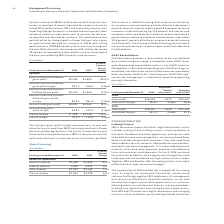According to International Business Machines's financial document, What led to increase in Global Financing total revenue? an increase in internal revenue, partially offset by a decrease in external revenue.. The document states: "se in Global Financing total revenue was driven by an increase in internal revenue, partially offset by a decrease in external revenue. Internal reven..." Also, What led to decline in External revenue  a decrease in external used equipment sales (down 30.8 percent), partially offset by an increase in external financing (up 4.9 percent).. The document states: "ent). External revenue declined 6.3 percent due to a decrease in external used equipment sales (down 30.8 percent), partially offset by an increase in..." Also, What led to increase in Global Financing pre-tax income? an increase in gross profit and a decrease in total expense.. The document states: "l Financing pre-tax income was primarily driven by an increase in gross profit and a decrease in total expense...." Also, can you calculate: What is the increase/ (decrease) in External revenue from 2017 to 2018 Based on the calculation: 1,590-1,696, the result is -106 (in millions). This is based on the information: "External revenue $1,590 $1,696 (6.3)% External revenue $1,590 $1,696 (6.3)%..." The key data points involved are: 1,590, 1,696. Also, can you calculate: What is the increase/ (decrease) in Internal Revenue from 2017 to 2018 Based on the calculation: 1,610-1,471 , the result is 139 (in millions). This is based on the information: "Internal revenue 1,610 1,471 9.5 Internal revenue 1,610 1,471 9.5..." The key data points involved are: 1,471, 1,610. Also, can you calculate: What is the average of Internal Revenue? To answer this question, I need to perform calculations using the financial data. The calculation is: (1,610+1,471) / 2, which equals 1540.5 (in millions). This is based on the information: "Internal revenue 1,610 1,471 9.5 Internal revenue 1,610 1,471 9.5..." The key data points involved are: 1,471, 1,610. 